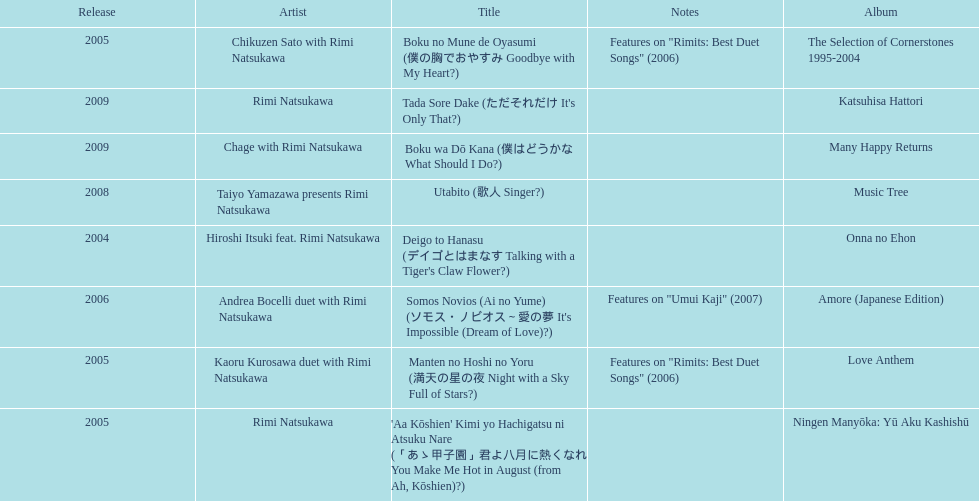Can you give me this table as a dict? {'header': ['Release', 'Artist', 'Title', 'Notes', 'Album'], 'rows': [['2005', 'Chikuzen Sato with Rimi Natsukawa', 'Boku no Mune de Oyasumi (僕の胸でおやすみ Goodbye with My Heart?)', 'Features on "Rimits: Best Duet Songs" (2006)', 'The Selection of Cornerstones 1995-2004'], ['2009', 'Rimi Natsukawa', "Tada Sore Dake (ただそれだけ It's Only That?)", '', 'Katsuhisa Hattori'], ['2009', 'Chage with Rimi Natsukawa', 'Boku wa Dō Kana (僕はどうかな What Should I Do?)', '', 'Many Happy Returns'], ['2008', 'Taiyo Yamazawa presents Rimi Natsukawa', 'Utabito (歌人 Singer?)', '', 'Music Tree'], ['2004', 'Hiroshi Itsuki feat. Rimi Natsukawa', "Deigo to Hanasu (デイゴとはまなす Talking with a Tiger's Claw Flower?)", '', 'Onna no Ehon'], ['2006', 'Andrea Bocelli duet with Rimi Natsukawa', "Somos Novios (Ai no Yume) (ソモス・ノビオス～愛の夢 It's Impossible (Dream of Love)?)", 'Features on "Umui Kaji" (2007)', 'Amore (Japanese Edition)'], ['2005', 'Kaoru Kurosawa duet with Rimi Natsukawa', 'Manten no Hoshi no Yoru (満天の星の夜 Night with a Sky Full of Stars?)', 'Features on "Rimits: Best Duet Songs" (2006)', 'Love Anthem'], ['2005', 'Rimi Natsukawa', "'Aa Kōshien' Kimi yo Hachigatsu ni Atsuku Nare (「あゝ甲子園」君よ八月に熱くなれ You Make Me Hot in August (from Ah, Kōshien)?)", '', 'Ningen Manyōka: Yū Aku Kashishū']]} How many titles are attributed to a single artist? 2. 